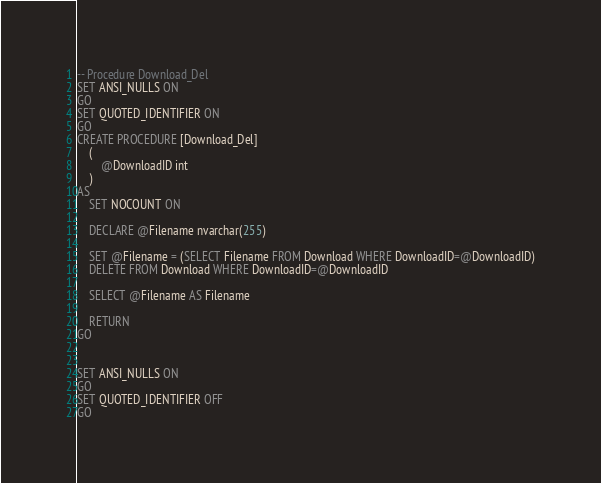Convert code to text. <code><loc_0><loc_0><loc_500><loc_500><_SQL_>
-- Procedure Download_Del
SET ANSI_NULLS ON
GO
SET QUOTED_IDENTIFIER ON
GO
CREATE PROCEDURE [Download_Del] 
	(
		@DownloadID int
	)
AS
	SET NOCOUNT ON
	
	DECLARE @Filename nvarchar(255)
	
	SET @Filename = (SELECT Filename FROM Download WHERE DownloadID=@DownloadID)
	DELETE FROM Download WHERE DownloadID=@DownloadID
	
	SELECT @Filename AS Filename
	
	RETURN
GO


SET ANSI_NULLS ON
GO
SET QUOTED_IDENTIFIER OFF
GO

</code> 